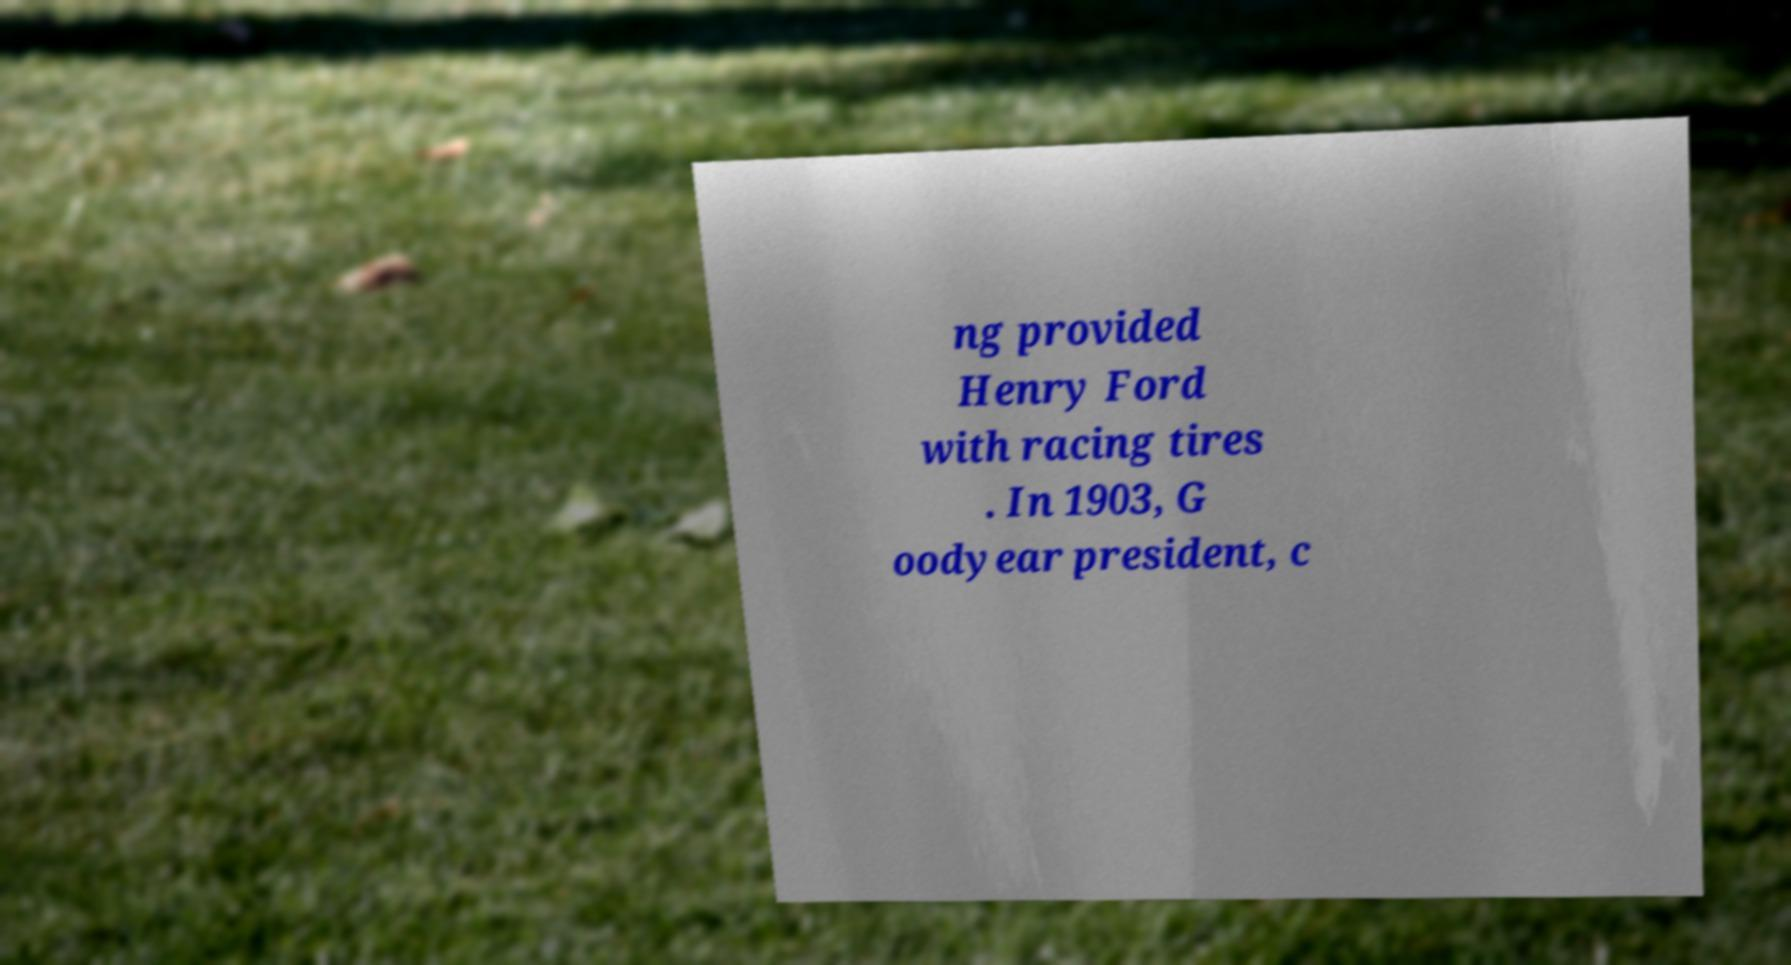Could you assist in decoding the text presented in this image and type it out clearly? ng provided Henry Ford with racing tires . In 1903, G oodyear president, c 